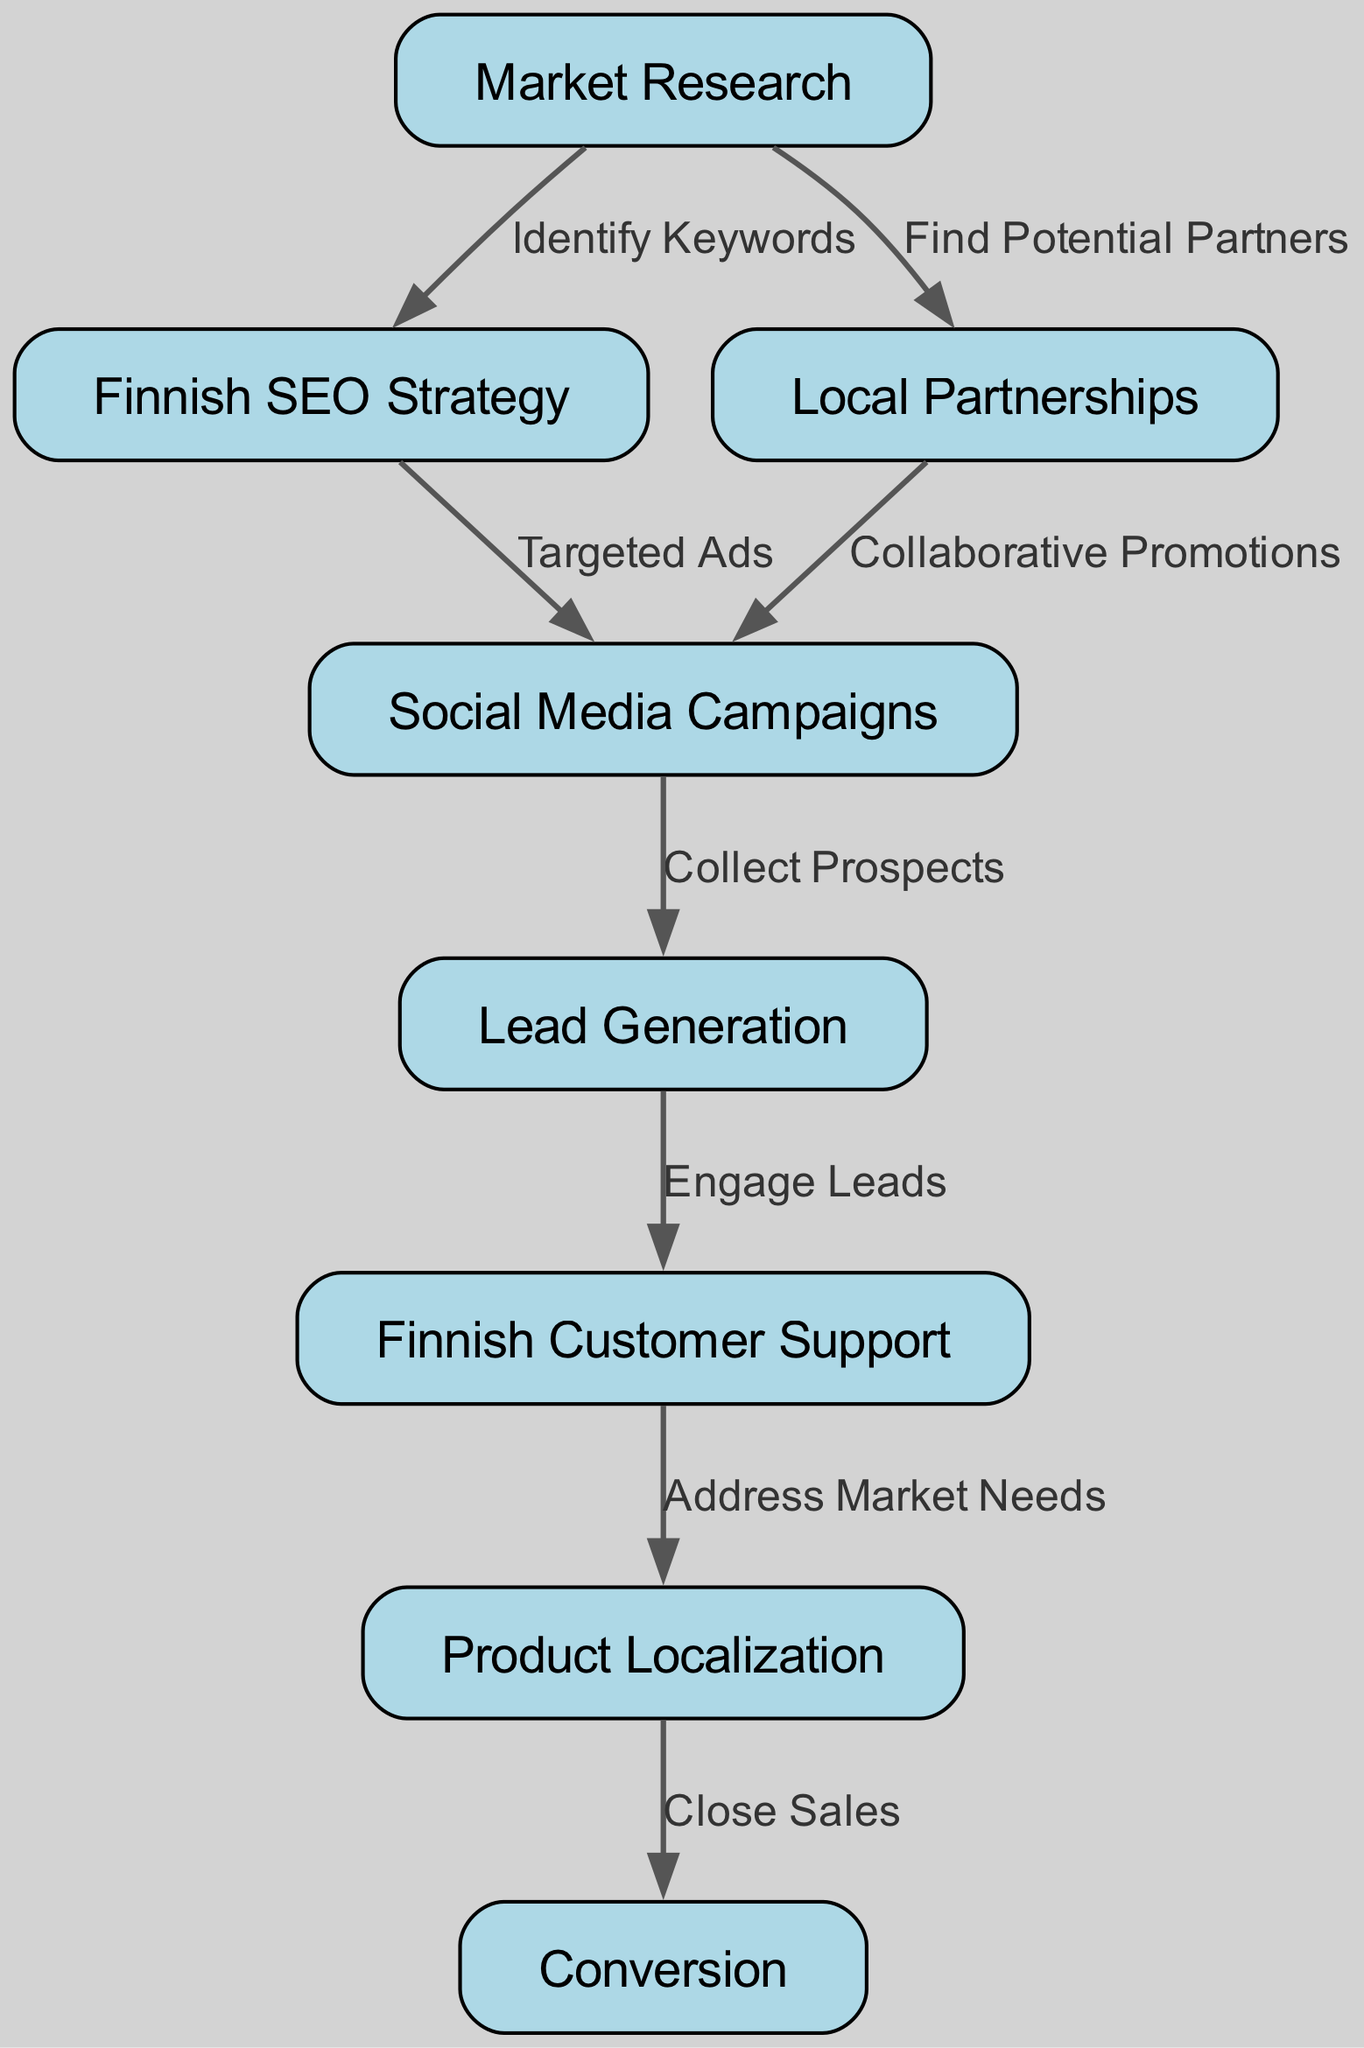What is the first step in the customer acquisition funnel? The first step in the customer acquisition funnel is "Market Research," which is the starting node of the flowchart.
Answer: Market Research How many nodes are there in the diagram? To determine the number of nodes, we can count the data provided in the nodes section. There are 8 unique nodes listed in the data.
Answer: 8 What connection leads to "Lead Generation"? "Lead Generation" is connected to two preceding nodes: "Social Media Campaigns" and is reached after "Collect Prospects."
Answer: Social Media Campaigns; Collect Prospects Which node directly follows "Finnish SEO Strategy"? After "Finnish SEO Strategy," the next node is "Social Media Campaigns," as indicated by the directed edge from node 2 to node 4.
Answer: Social Media Campaigns What action comes after engaging leads? After "Engage Leads," the next action is to provide "Finnish Customer Support," which is indicated by a direct connection from node 5 to node 6 in the diagram.
Answer: Finnish Customer Support What action precedes "Close Sales"? The action that comes before "Close Sales" is "Product Localization," based on the flow from node 7 to node 8 in the flowchart.
Answer: Product Localization What type of promotions are identified following "Local Partnerships"? Following "Local Partnerships," the type of promotions conducted is "Collaborative Promotions," as indicated by the edge connecting node 3 to node 4.
Answer: Collaborative Promotions Which node has the most connections? "Social Media Campaigns" is connected to three other nodes: it leads to "Lead Generation" and is linked to both "Finnish SEO Strategy" and "Local Partnerships." Hence, it has the highest number of connections in the diagram.
Answer: Social Media Campaigns 